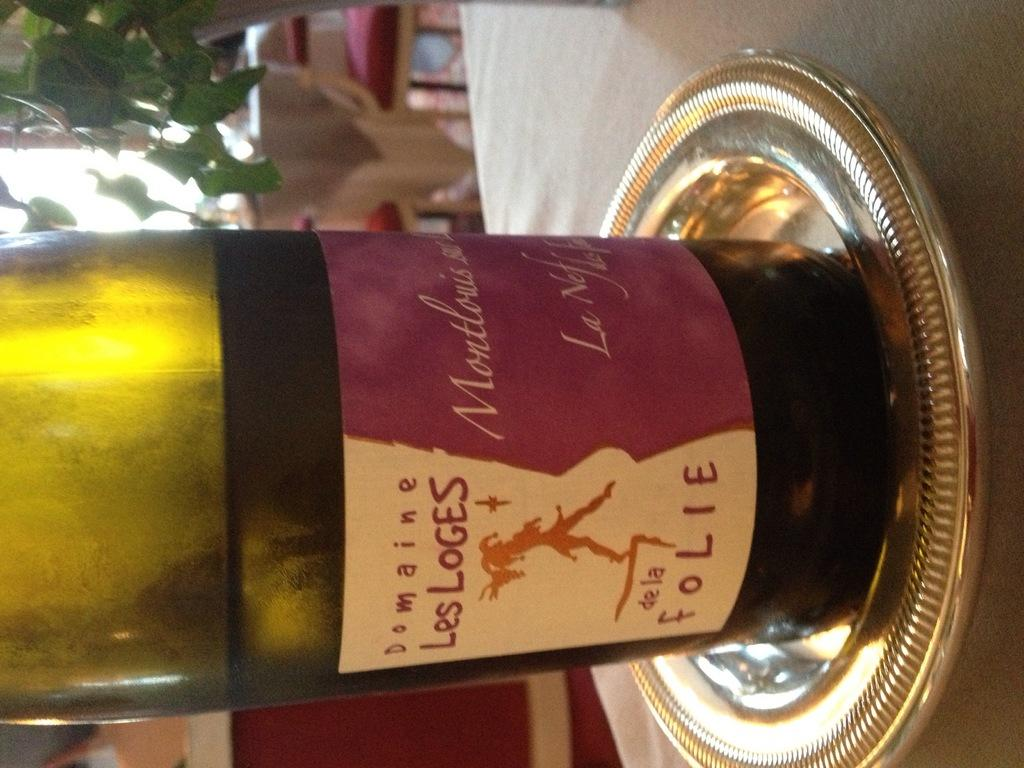<image>
Provide a brief description of the given image. a bottle of wine with Les Loges written on it 